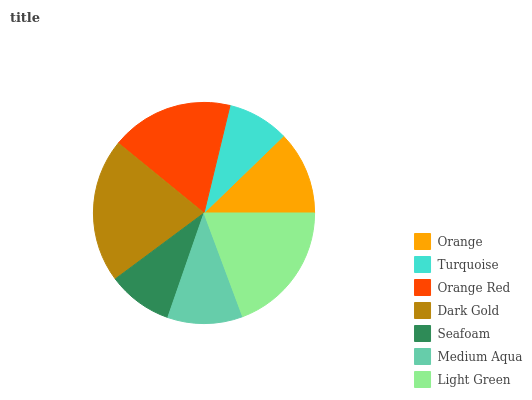Is Turquoise the minimum?
Answer yes or no. Yes. Is Dark Gold the maximum?
Answer yes or no. Yes. Is Orange Red the minimum?
Answer yes or no. No. Is Orange Red the maximum?
Answer yes or no. No. Is Orange Red greater than Turquoise?
Answer yes or no. Yes. Is Turquoise less than Orange Red?
Answer yes or no. Yes. Is Turquoise greater than Orange Red?
Answer yes or no. No. Is Orange Red less than Turquoise?
Answer yes or no. No. Is Orange the high median?
Answer yes or no. Yes. Is Orange the low median?
Answer yes or no. Yes. Is Dark Gold the high median?
Answer yes or no. No. Is Orange Red the low median?
Answer yes or no. No. 